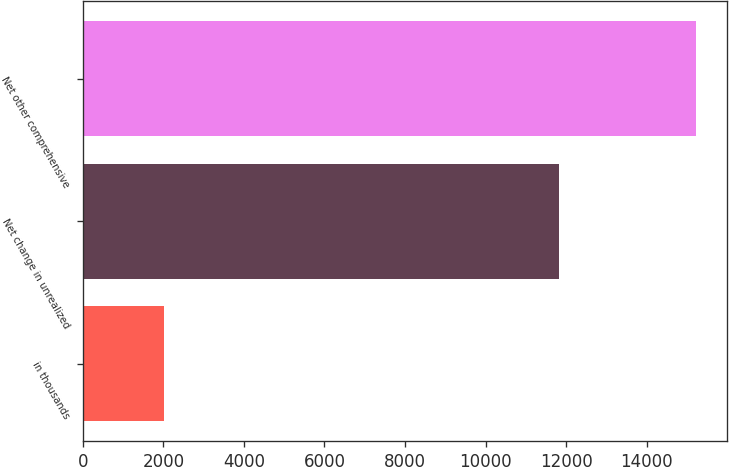Convert chart. <chart><loc_0><loc_0><loc_500><loc_500><bar_chart><fcel>in thousands<fcel>Net change in unrealized<fcel>Net other comprehensive<nl><fcel>2016<fcel>11833<fcel>15230<nl></chart> 